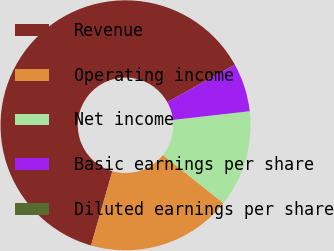Convert chart to OTSL. <chart><loc_0><loc_0><loc_500><loc_500><pie_chart><fcel>Revenue<fcel>Operating income<fcel>Net income<fcel>Basic earnings per share<fcel>Diluted earnings per share<nl><fcel>62.5%<fcel>18.75%<fcel>12.5%<fcel>6.25%<fcel>0.0%<nl></chart> 